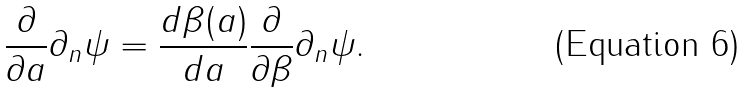Convert formula to latex. <formula><loc_0><loc_0><loc_500><loc_500>\frac { \partial } { \partial a } \partial _ { n } \psi = \frac { d \beta ( a ) } { d a } \frac { \partial } { \partial \beta } \partial _ { n } \psi .</formula> 